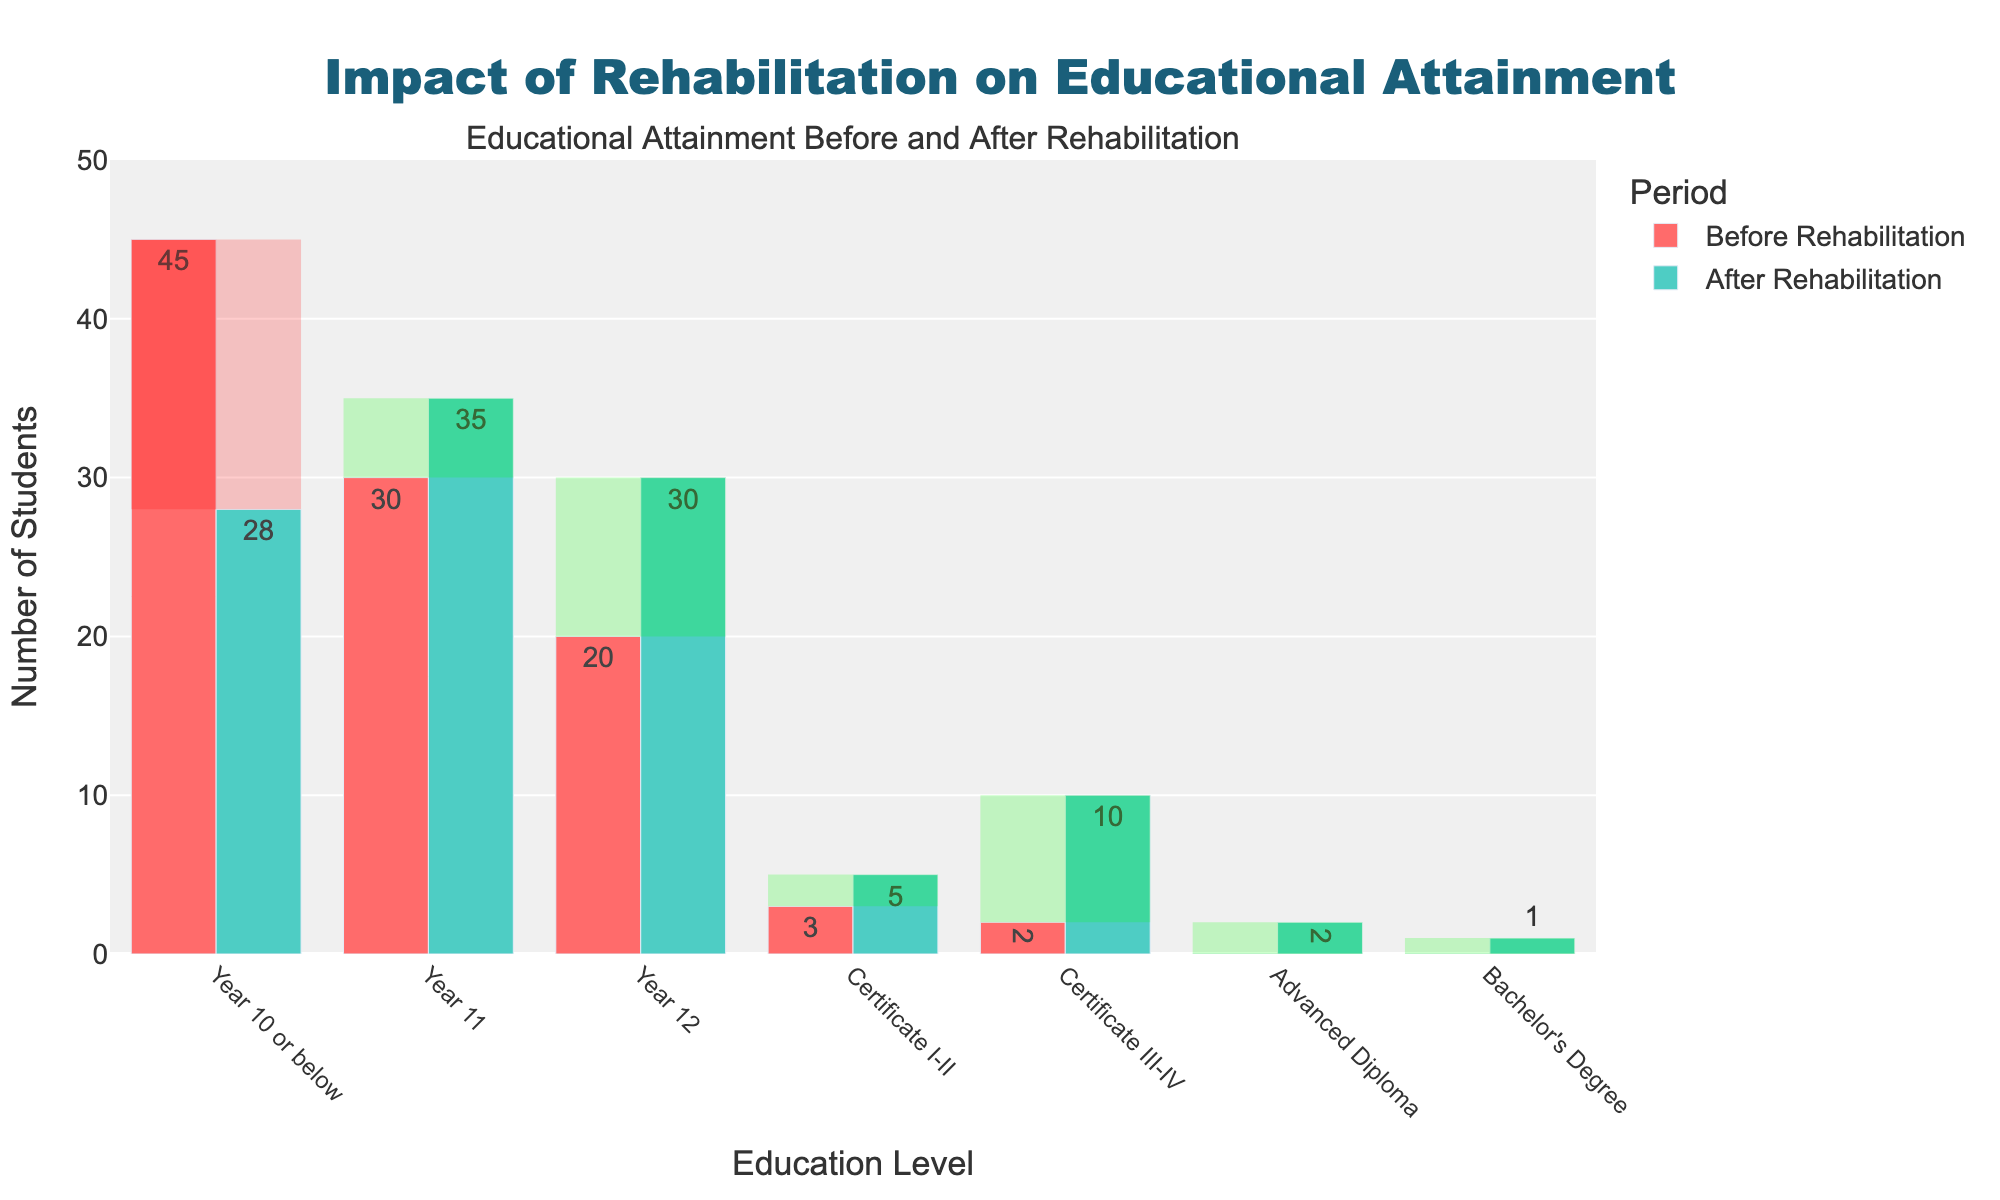Which education level saw the largest increase in the number of students after rehabilitation? To determine this, look at the difference between the 'After Rehabilitation' and 'Before Rehabilitation' bars for each education level and find the largest positive difference. The largest increase is from Year 12 (30 - 20 = 10 students).
Answer: Year 12 Which education level had no students before rehabilitation but had some students after rehabilitation? This can be identified by finding bars with zero height in the 'Before Rehabilitation' group and non-zero height in the 'After Rehabilitation' group. Advanced Diploma and Bachelor's Degree both match this condition.
Answer: Advanced Diploma, Bachelor's Degree How many more students achieved a Certificate III-IV after rehabilitation compared to before? Subtract the 'Before Rehabilitation' value from the 'After Rehabilitation' value for the Certificate III-IV education level. The difference is 10 - 2 = 8 students.
Answer: 8 What is the total number of students at Year 11 level before and after rehabilitation combined? Add the 'Before Rehabilitation' and 'After Rehabilitation' values for the Year 11 education level. The total is 30 + 35 = 65 students.
Answer: 65 Which education level decreased after rehabilitation compared to before, and by how much? Compare the 'Before Rehabilitation' and 'After Rehabilitation' values and find the levels where the latter is lower. Year 10 or below is such a level, decreasing by 45 - 28 = 17 students.
Answer: Year 10 or below decreased by 17 What is the percentage increase in the number of students with a Certificate I-II after rehabilitation? Use the formula ((After - Before) / Before) * 100 to calculate, with values: ((5 - 3) / 3) * 100 = 66.67%.
Answer: 66.67% Which education level had the highest number of students after rehabilitation? Identify the highest bar in the 'After Rehabilitation' group. Year 11 had the highest with 35 students.
Answer: Year 11 How many total students achieved Year 12 level or higher after rehabilitation? Sum the 'After Rehabilitation' values for Year 12, Certificate I-II, Certificate III-IV, Advanced Diploma, and Bachelor's Degree: 30 + 5 + 10 + 2 + 1 = 48.
Answer: 48 